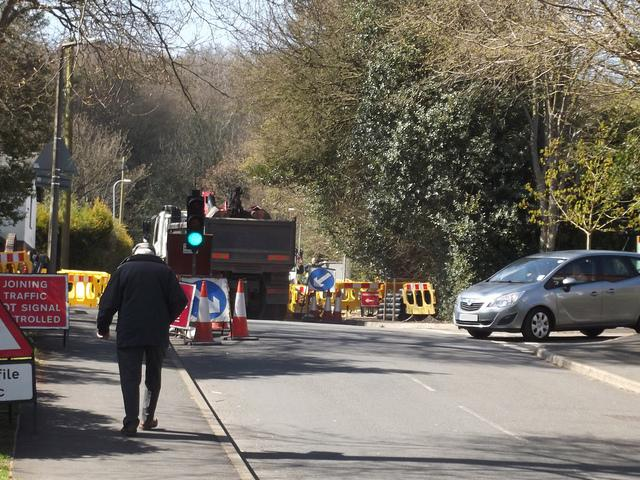What is the possible danger that will occur in the scene? accident 